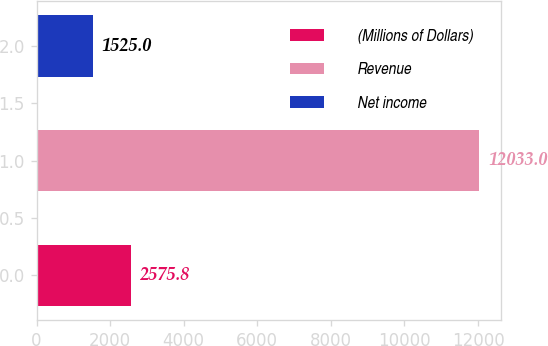<chart> <loc_0><loc_0><loc_500><loc_500><bar_chart><fcel>(Millions of Dollars)<fcel>Revenue<fcel>Net income<nl><fcel>2575.8<fcel>12033<fcel>1525<nl></chart> 